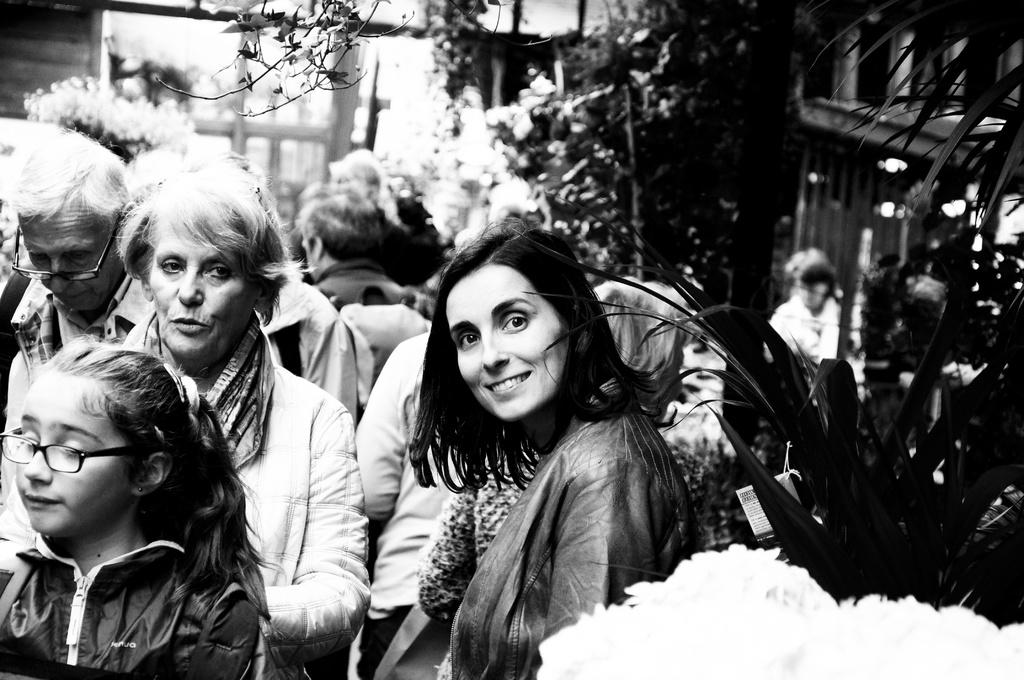What is the main subject of the image? The main subject of the image is a group of people. Can you describe any specific features of the people in the group? Some people in the group are wearing spectacles. Who is the central figure in the image? There is a woman in the middle of the image. What is the woman's expression in the image? The woman is smiling. What can be seen in the background of the image? There are trees in the background of the image. What type of pipe can be seen in the image? There is no pipe present in the image. What is the floor made of in the image? The image does not show the floor, so it cannot be determined what material it is made of. 